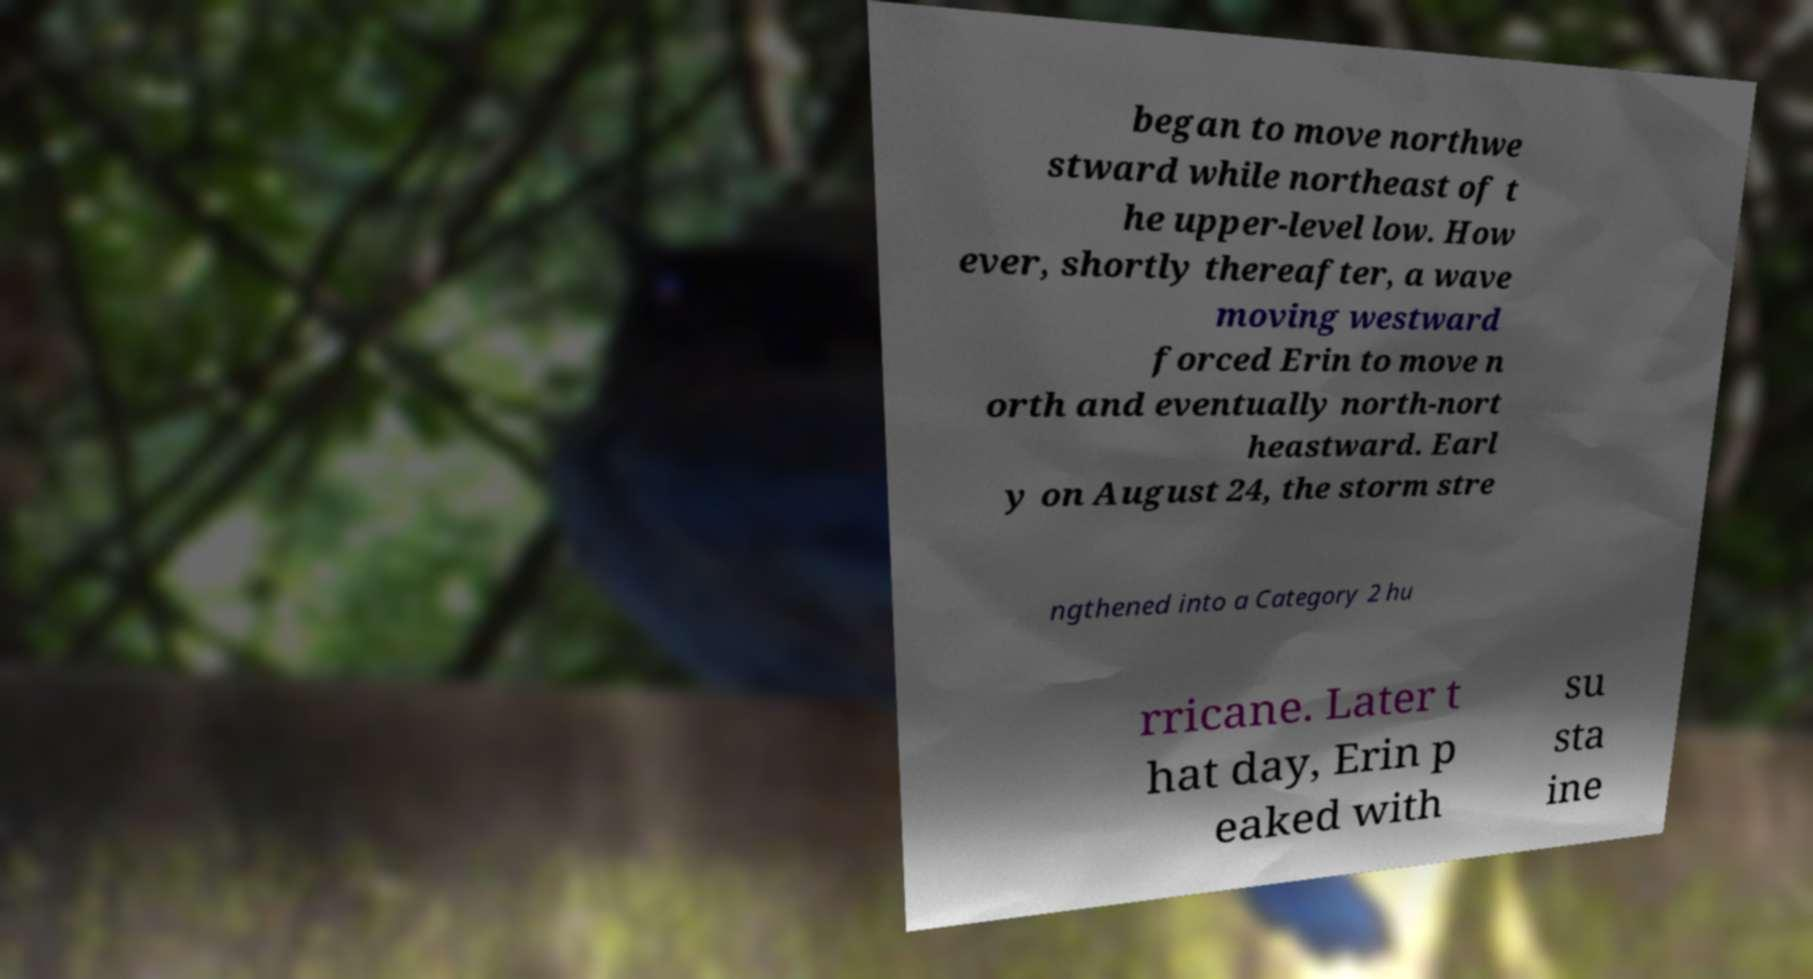Could you extract and type out the text from this image? began to move northwe stward while northeast of t he upper-level low. How ever, shortly thereafter, a wave moving westward forced Erin to move n orth and eventually north-nort heastward. Earl y on August 24, the storm stre ngthened into a Category 2 hu rricane. Later t hat day, Erin p eaked with su sta ine 